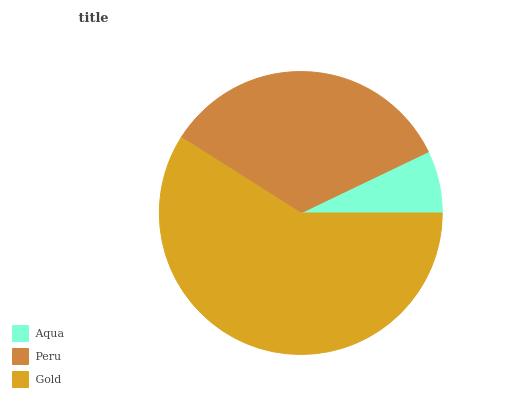Is Aqua the minimum?
Answer yes or no. Yes. Is Gold the maximum?
Answer yes or no. Yes. Is Peru the minimum?
Answer yes or no. No. Is Peru the maximum?
Answer yes or no. No. Is Peru greater than Aqua?
Answer yes or no. Yes. Is Aqua less than Peru?
Answer yes or no. Yes. Is Aqua greater than Peru?
Answer yes or no. No. Is Peru less than Aqua?
Answer yes or no. No. Is Peru the high median?
Answer yes or no. Yes. Is Peru the low median?
Answer yes or no. Yes. Is Aqua the high median?
Answer yes or no. No. Is Aqua the low median?
Answer yes or no. No. 